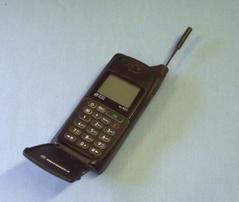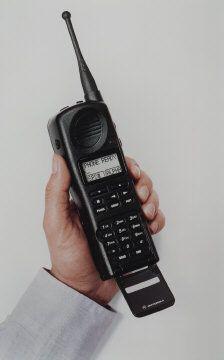The first image is the image on the left, the second image is the image on the right. For the images displayed, is the sentence "Both phones are pointing to the right." factually correct? Answer yes or no. No. 